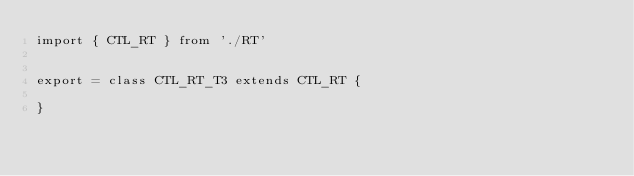<code> <loc_0><loc_0><loc_500><loc_500><_TypeScript_>import { CTL_RT } from './RT'


export = class CTL_RT_T3 extends CTL_RT {

}</code> 